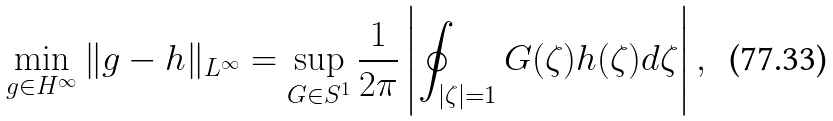<formula> <loc_0><loc_0><loc_500><loc_500>\min _ { g \in H ^ { \infty } } \| g - h \| _ { L ^ { \infty } } = \sup _ { G \in S ^ { 1 } } \frac { 1 } { 2 \pi } \left | \oint _ { | \zeta | = 1 } G ( \zeta ) h ( \zeta ) d \zeta \right | ,</formula> 